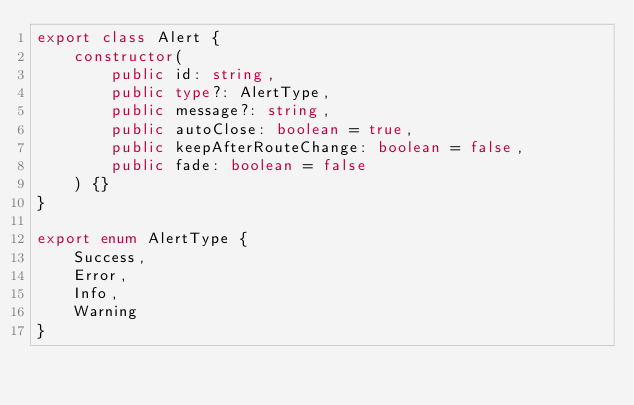<code> <loc_0><loc_0><loc_500><loc_500><_TypeScript_>export class Alert {
    constructor(
        public id: string,
        public type?: AlertType,
        public message?: string,
        public autoClose: boolean = true,
        public keepAfterRouteChange: boolean = false,
        public fade: boolean = false
    ) {}
}

export enum AlertType {
    Success,
    Error,
    Info,
    Warning
}
</code> 